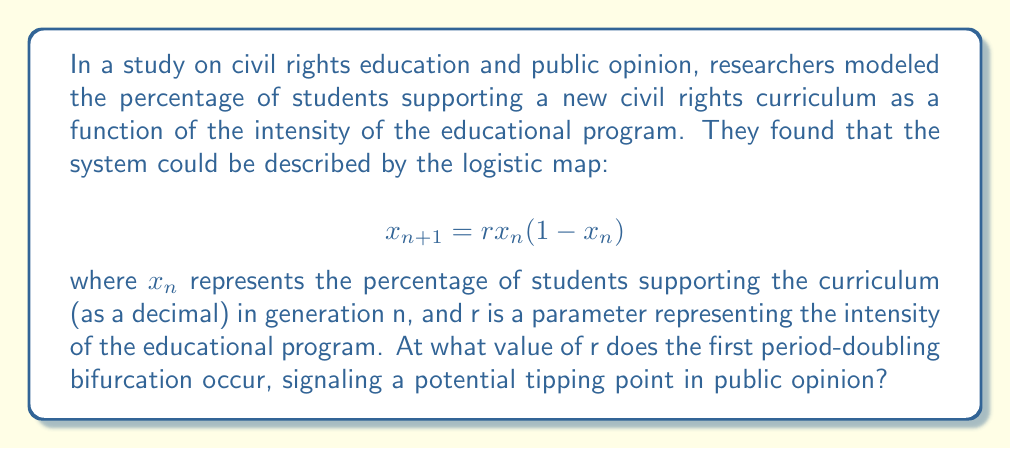What is the answer to this math problem? To find the first period-doubling bifurcation in the logistic map, we need to follow these steps:

1) The fixed points of the logistic map are given by solving:
   $$x = rx(1-x)$$

2) This equation has two solutions:
   $$x = 0$$ and $$x = 1 - \frac{1}{r}$$

3) The non-zero fixed point is stable when:
   $$\left|\frac{d}{dx}(rx(1-x))\right|_{x=1-\frac{1}{r}} < 1$$

4) Calculating this derivative:
   $$\frac{d}{dx}(rx(1-x)) = r(1-2x)$$

5) Evaluating at the non-zero fixed point:
   $$\left|r(1-2(1-\frac{1}{r}))\right| = |2-r| < 1$$

6) Solving this inequality:
   $$-1 < 2-r < 1$$
   $$1 < r < 3$$

7) The first period-doubling bifurcation occurs when the inequality becomes an equality:
   $$2-r = -1$$
   $$r = 3$$

This value of r represents the tipping point where the system transitions from a stable fixed point to a period-2 cycle, potentially signaling a significant shift in public opinion dynamics.
Answer: $r = 3$ 